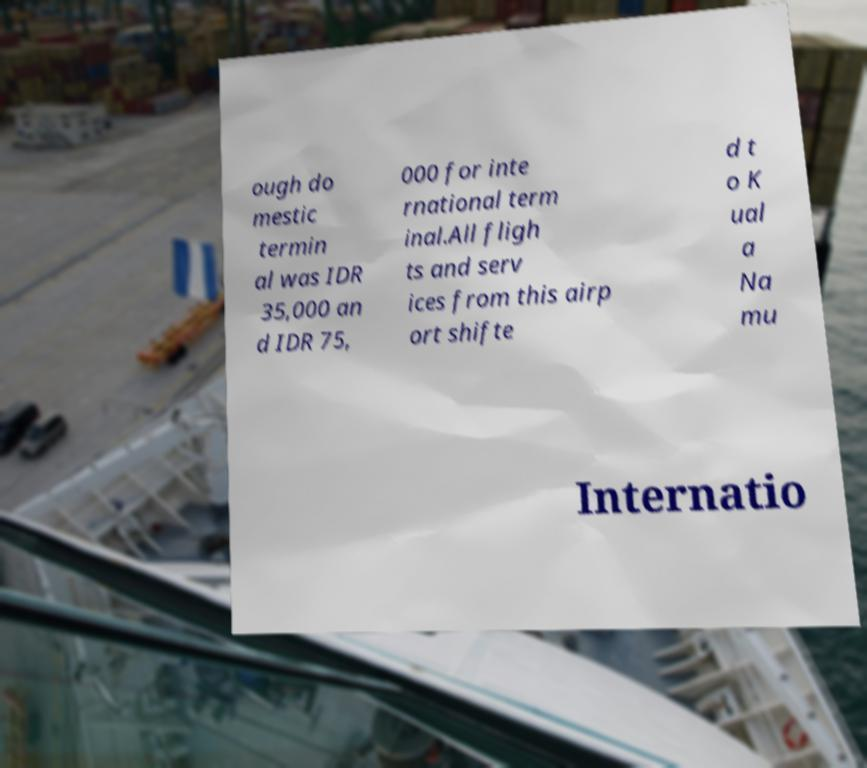Can you accurately transcribe the text from the provided image for me? ough do mestic termin al was IDR 35,000 an d IDR 75, 000 for inte rnational term inal.All fligh ts and serv ices from this airp ort shifte d t o K ual a Na mu Internatio 